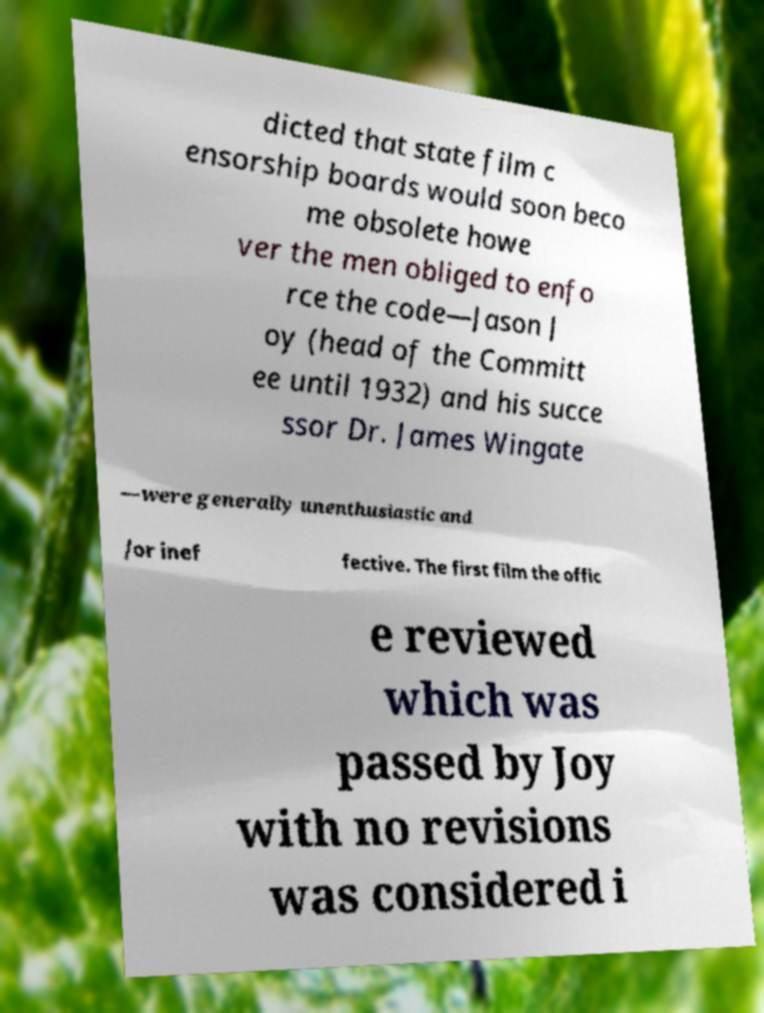Can you read and provide the text displayed in the image?This photo seems to have some interesting text. Can you extract and type it out for me? dicted that state film c ensorship boards would soon beco me obsolete howe ver the men obliged to enfo rce the code—Jason J oy (head of the Committ ee until 1932) and his succe ssor Dr. James Wingate —were generally unenthusiastic and /or inef fective. The first film the offic e reviewed which was passed by Joy with no revisions was considered i 